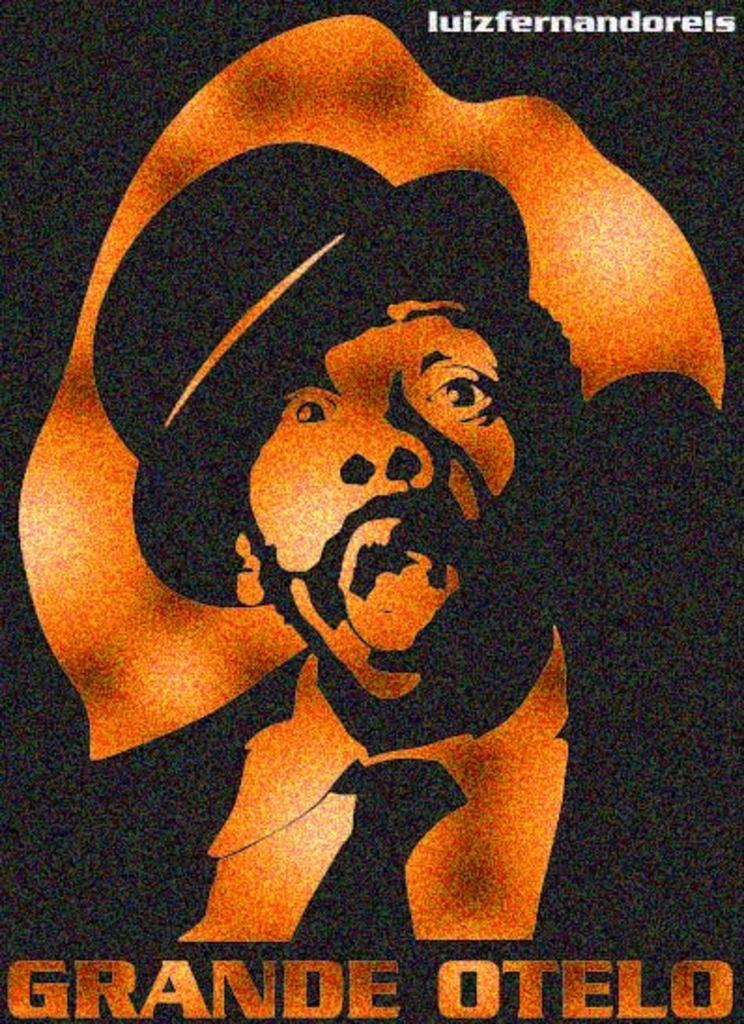<image>
Present a compact description of the photo's key features. a poster for Grande otelo in black and gold. 